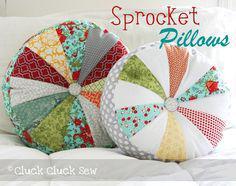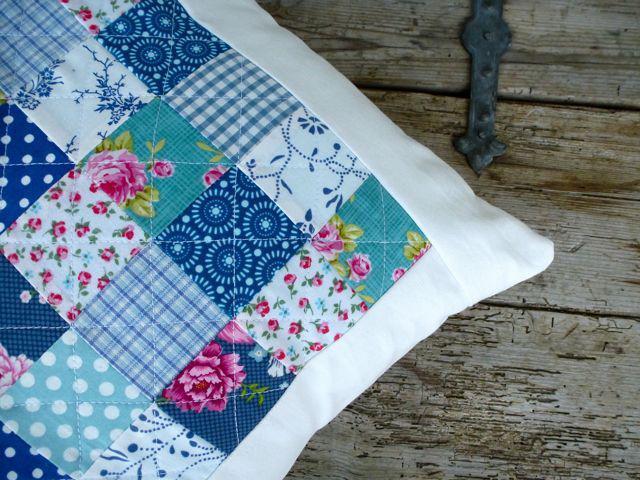The first image is the image on the left, the second image is the image on the right. Analyze the images presented: Is the assertion "The pillow display in one image includes a round wheel shape with a button center." valid? Answer yes or no. Yes. The first image is the image on the left, the second image is the image on the right. For the images displayed, is the sentence "Some of the pillows are round in shape." factually correct? Answer yes or no. Yes. 